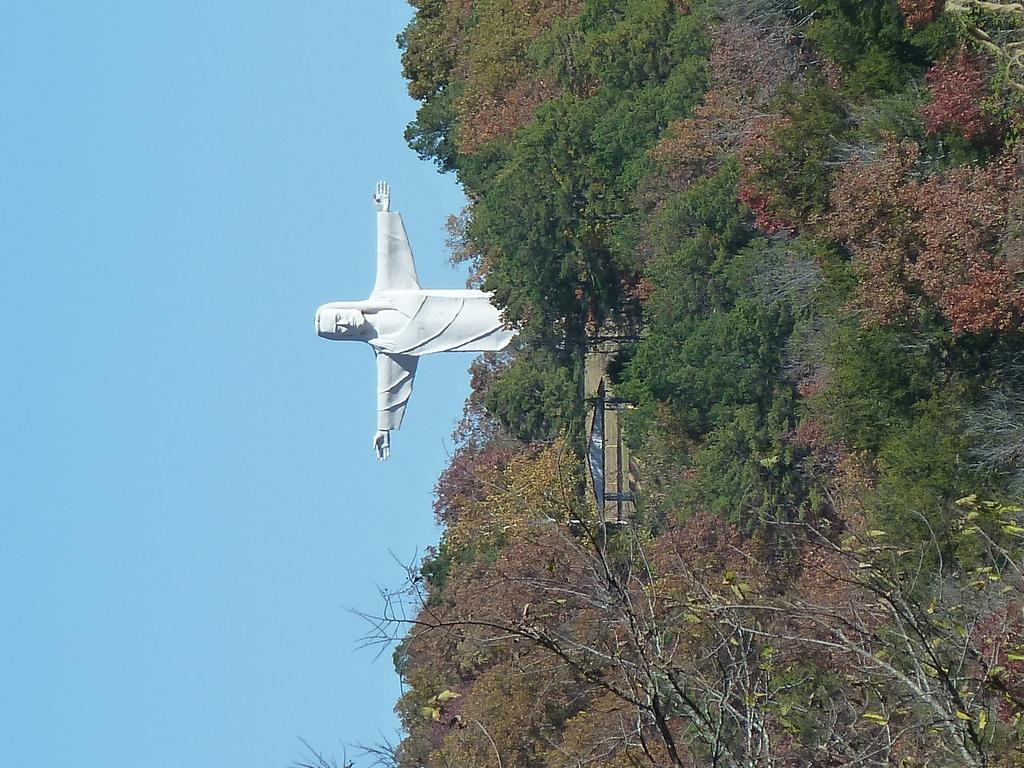What is the main subject in the image? There is a statue of a person standing in the image. What other structures or objects can be seen in the image? There is a shed in the image. What type of natural elements are present in the image? There are trees in the image. What part of the sky is visible in the image? The sky is visible on the left side of the image. What type of book is the statue reading in the image? There is no book present in the image, as the statue is not depicted as reading. 